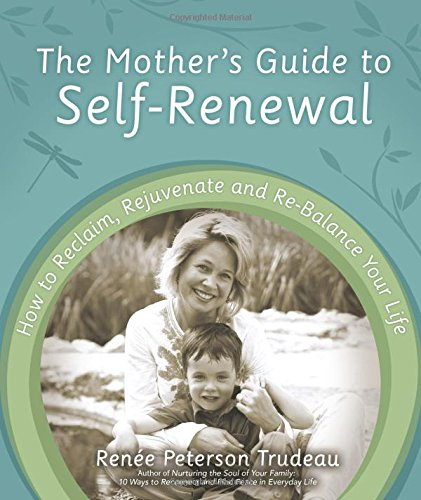Who wrote this book?
Answer the question using a single word or phrase. Renée Peterson Trudeau What is the title of this book? The Mother's Guide to Self-Renewal: How to Reclaim, Rejuvenate and Re-Balance Your Life What type of book is this? Science & Math Is this book related to Science & Math? Yes Is this book related to Christian Books & Bibles? No 